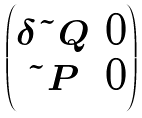<formula> <loc_0><loc_0><loc_500><loc_500>\begin{pmatrix} \delta \tilde { Q } & 0 \\ \tilde { P } & 0 \end{pmatrix}</formula> 